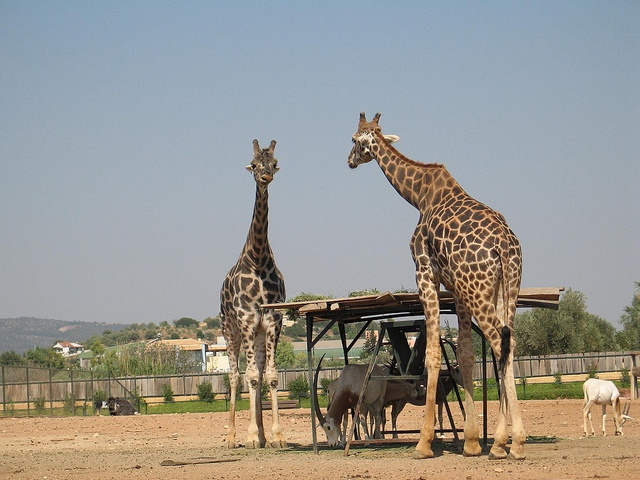Describe the objects in this image and their specific colors. I can see giraffe in darkgray, maroon, gray, and tan tones and giraffe in darkgray, gray, black, and tan tones in this image. 